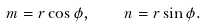Convert formula to latex. <formula><loc_0><loc_0><loc_500><loc_500>m = r \cos \phi , \quad n = r \sin \phi .</formula> 